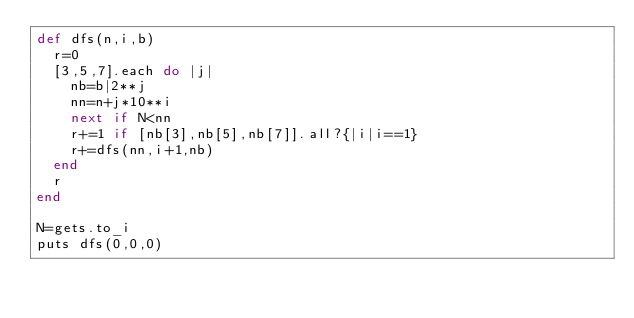<code> <loc_0><loc_0><loc_500><loc_500><_Ruby_>def dfs(n,i,b)
  r=0
  [3,5,7].each do |j|
    nb=b|2**j
    nn=n+j*10**i
    next if N<nn
    r+=1 if [nb[3],nb[5],nb[7]].all?{|i|i==1}
    r+=dfs(nn,i+1,nb)
  end
  r
end

N=gets.to_i
puts dfs(0,0,0)
</code> 